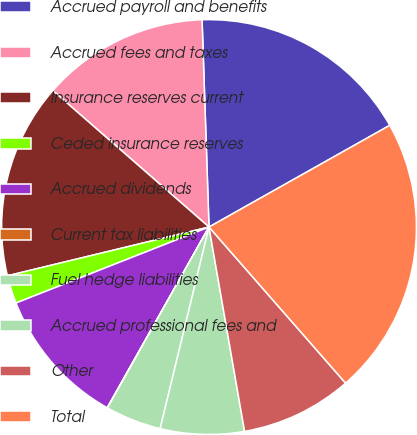<chart> <loc_0><loc_0><loc_500><loc_500><pie_chart><fcel>Accrued payroll and benefits<fcel>Accrued fees and taxes<fcel>Insurance reserves current<fcel>Ceded insurance reserves<fcel>Accrued dividends<fcel>Current tax liabilities<fcel>Fuel hedge liabilities<fcel>Accrued professional fees and<fcel>Other<fcel>Total<nl><fcel>17.38%<fcel>13.04%<fcel>15.21%<fcel>2.19%<fcel>10.87%<fcel>0.02%<fcel>4.36%<fcel>6.53%<fcel>8.7%<fcel>21.72%<nl></chart> 